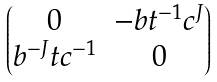Convert formula to latex. <formula><loc_0><loc_0><loc_500><loc_500>\begin{pmatrix} 0 & - b t ^ { - 1 } c ^ { J } \\ b ^ { - J } t c ^ { - 1 } & 0 \end{pmatrix}</formula> 